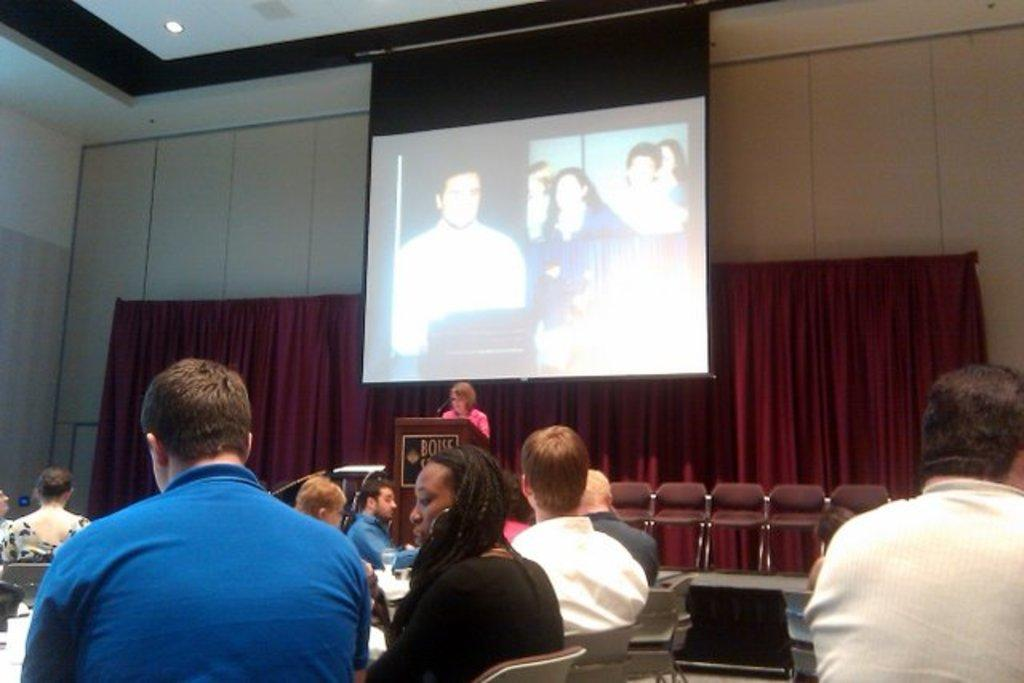How many people can be seen in the image? There are many people sitting in the image. What are the people wearing? The people are wearing clothes. What type of furniture is present in the image? There are chairs in the image. What is the main feature of the stage in the image? There is a podium in the image. What device is used for amplifying sound in the image? There is a microphone in the image. What is being projected on the screen in the image? The image does not provide information about what is being projected on the screen. What type of lighting is present in the image? There is light in the image. What type of window treatment is present in the image? There are curtains in the image. What color are the curtains? The curtains are maroon in color. How many grains of rice are on the back of the hour hand in the image? There is no hour hand or rice present in the image. What type of animal is walking on the stage in the image? There are no animals or walking depicted in the image. 